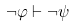<formula> <loc_0><loc_0><loc_500><loc_500>\neg \varphi \vdash \neg \psi</formula> 